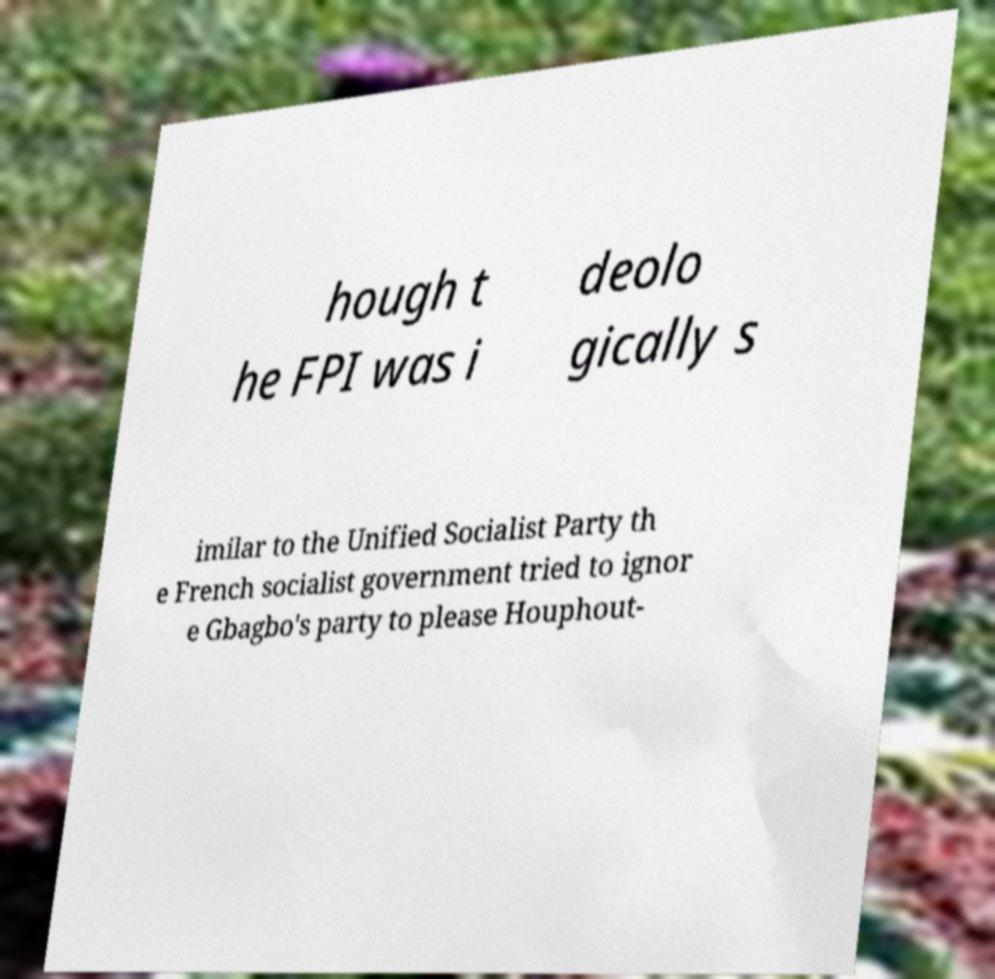Can you read and provide the text displayed in the image?This photo seems to have some interesting text. Can you extract and type it out for me? hough t he FPI was i deolo gically s imilar to the Unified Socialist Party th e French socialist government tried to ignor e Gbagbo's party to please Houphout- 